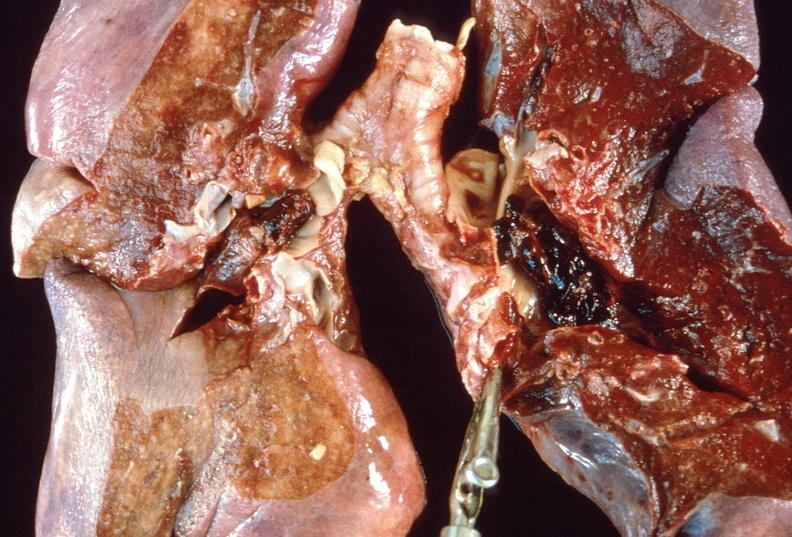what does this image show?
Answer the question using a single word or phrase. Pulmonary thromboemboli 